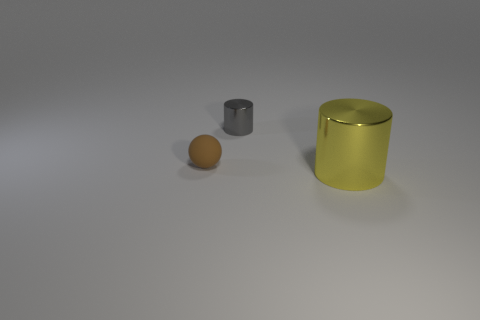Is there any other thing that is the same size as the yellow thing?
Keep it short and to the point. No. Do the yellow object and the object on the left side of the tiny shiny thing have the same size?
Offer a terse response. No. What number of small gray cylinders are behind the metal thing that is in front of the small brown matte object that is to the left of the gray thing?
Give a very brief answer. 1. There is a gray metallic cylinder; how many rubber spheres are on the right side of it?
Offer a very short reply. 0. What is the color of the metal cylinder that is to the left of the cylinder that is on the right side of the tiny gray shiny object?
Make the answer very short. Gray. How many other objects are the same material as the small sphere?
Your answer should be compact. 0. Are there the same number of big cylinders behind the gray object and small brown things?
Make the answer very short. No. What is the material of the small object left of the cylinder that is left of the shiny thing that is in front of the brown thing?
Your answer should be compact. Rubber. There is a metallic object on the left side of the yellow metallic thing; what is its color?
Your answer should be very brief. Gray. Is there any other thing that has the same shape as the tiny brown matte thing?
Give a very brief answer. No. 